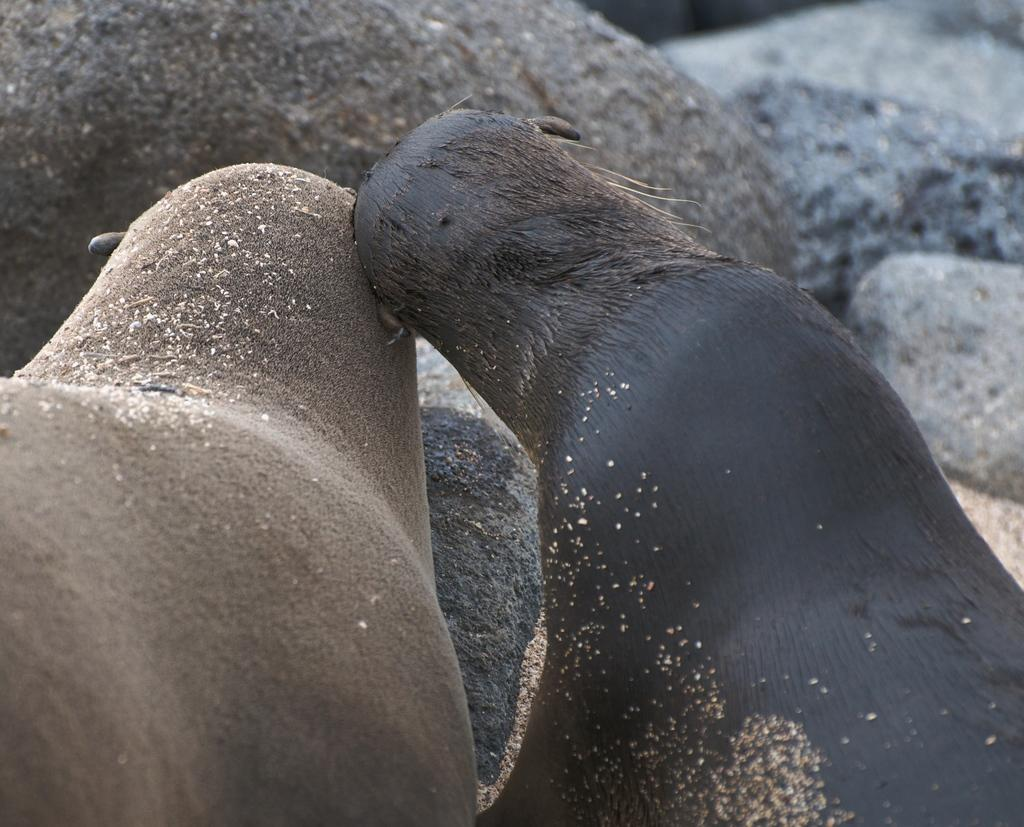What type of animals can be seen in the image? There are two black color animals in the image. Can you describe the background of the image? There are rocks in the background of the image. What type of punishment is being given to the animals in the image? There is no indication of punishment in the image; it simply shows two black color animals. What game are the animals playing in the image? There is no game being played in the image; the animals are not engaged in any activity. 